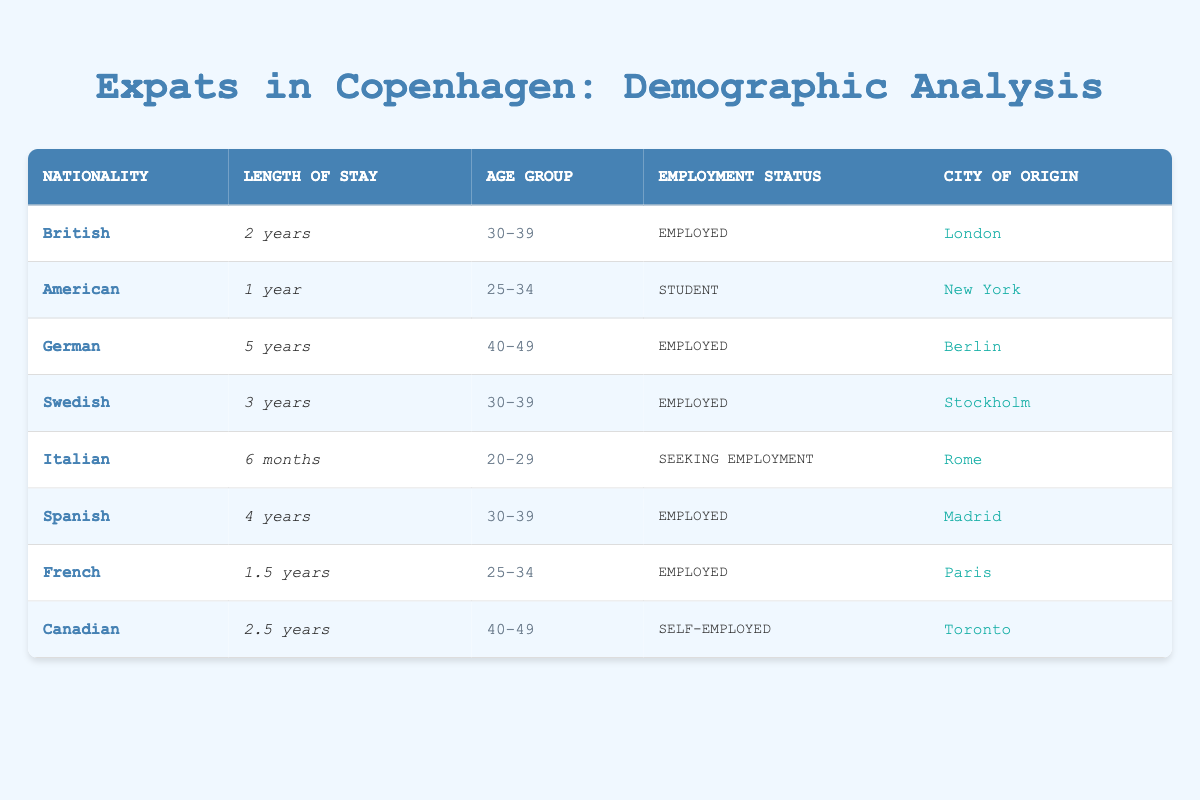What is the length of stay for the French expat? In the table, we can find the entry for the French national. The corresponding value in the "Length of Stay" column for the French entry is "1.5 years."
Answer: 1.5 years Which nationality has the longest length of stay? To find the longest length of stay, we can compare the values in the "Length of Stay" column. The German expat has been in Copenhagen for "5 years," which is the longest duration among all entries.
Answer: German Are there any expats from Italy seeking employment? Looking at the table, we see the entry for the Italian expat, whose employment status is listed as "Seeking Employment." Therefore, the answer is yes.
Answer: Yes What is the average length of stay for expats aged 30-39? From the table, the expats in the age group 30-39 are British (2 years), Swedish (3 years), and Spanish (4 years). To find the average, we sum the lengths of stay: (2 + 3 + 4) = 9 years. There are 3 expats, so the average length of stay is 9/3 = 3 years.
Answer: 3 years How many expats in Copenhagen are employed? To determine the number of employed expats, we can review the "Employment Status" column. The employed individuals are British, German, Swedish, Spanish, and French, totaling five expats.
Answer: 5 